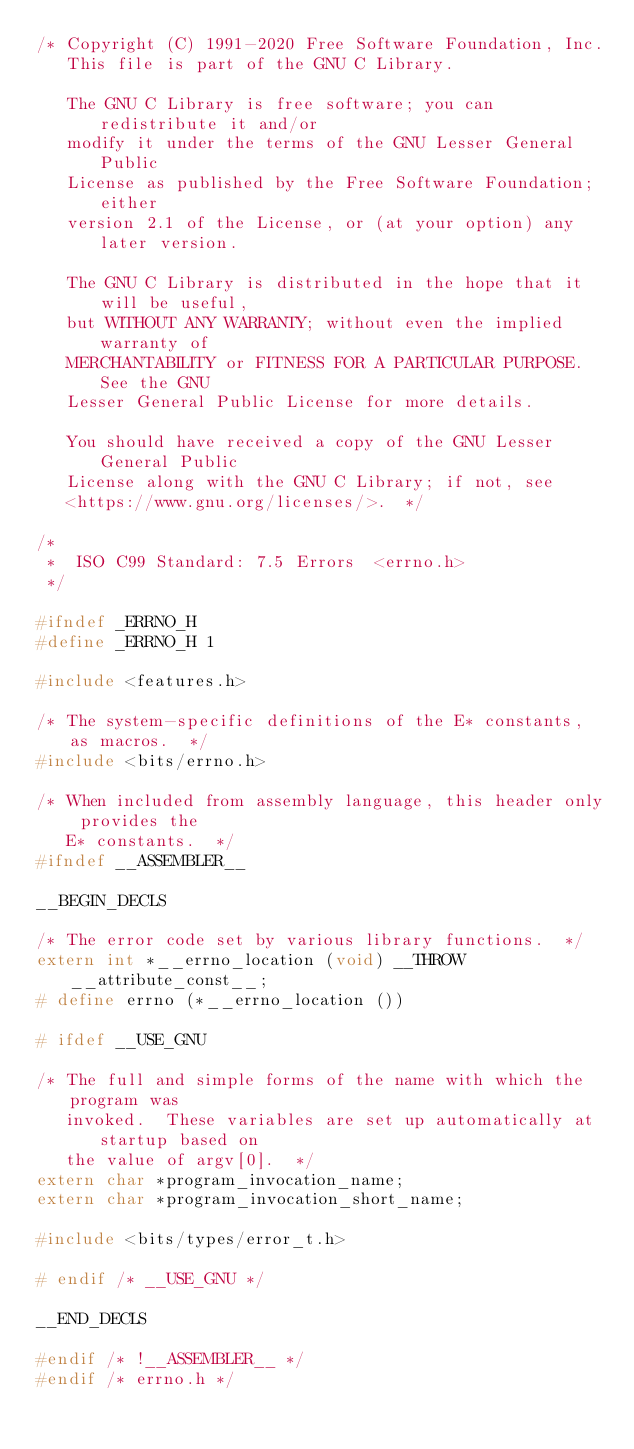<code> <loc_0><loc_0><loc_500><loc_500><_C_>/* Copyright (C) 1991-2020 Free Software Foundation, Inc.
   This file is part of the GNU C Library.

   The GNU C Library is free software; you can redistribute it and/or
   modify it under the terms of the GNU Lesser General Public
   License as published by the Free Software Foundation; either
   version 2.1 of the License, or (at your option) any later version.

   The GNU C Library is distributed in the hope that it will be useful,
   but WITHOUT ANY WARRANTY; without even the implied warranty of
   MERCHANTABILITY or FITNESS FOR A PARTICULAR PURPOSE.  See the GNU
   Lesser General Public License for more details.

   You should have received a copy of the GNU Lesser General Public
   License along with the GNU C Library; if not, see
   <https://www.gnu.org/licenses/>.  */

/*
 *	ISO C99 Standard: 7.5 Errors	<errno.h>
 */

#ifndef	_ERRNO_H
#define	_ERRNO_H 1

#include <features.h>

/* The system-specific definitions of the E* constants, as macros.  */
#include <bits/errno.h>

/* When included from assembly language, this header only provides the
   E* constants.  */
#ifndef __ASSEMBLER__

__BEGIN_DECLS

/* The error code set by various library functions.  */
extern int *__errno_location (void) __THROW __attribute_const__;
# define errno (*__errno_location ())

# ifdef __USE_GNU

/* The full and simple forms of the name with which the program was
   invoked.  These variables are set up automatically at startup based on
   the value of argv[0].  */
extern char *program_invocation_name;
extern char *program_invocation_short_name;

#include <bits/types/error_t.h>

# endif /* __USE_GNU */

__END_DECLS

#endif /* !__ASSEMBLER__ */
#endif /* errno.h */
</code> 